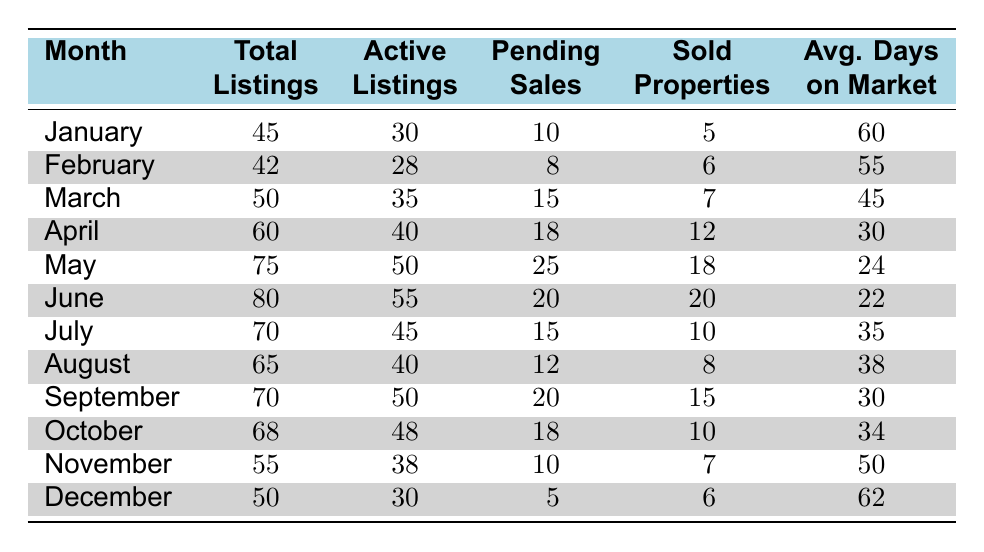What was the total number of listings in May? In May, the table shows a row for that month indicating that the total number of listings is 75.
Answer: 75 What are the average days on the market in June? Looking at the row for June, the average days on the market is listed as 22.
Answer: 22 How many sold properties were there in April? The table indicates that in April, there were 12 sold properties as per the respective row.
Answer: 12 What is the difference in active listings between January and February? In January, there are 30 active listings, and in February, there are 28. The difference is 30 - 28 = 2.
Answer: 2 Which month had the highest total listings? Upon reviewing the total listings for each month, May has the highest total with 75 listings.
Answer: May Was the number of pending sales higher in September than in October? In September, there are 20 pending sales, while in October there are 18. Thus, September has more pending sales.
Answer: Yes What is the sum of sold properties from January to March? Adding the sold properties from January (5), February (6), and March (7) gives us a total of 5 + 6 + 7 = 18.
Answer: 18 How did the average days on market change from February to July? In February, the average days on market is 55, and in July it is 35. The change is 55 - 35 = 20 less days on market.
Answer: 20 Which month had fewer total listings, November or December? In November, there are 55 total listings, while in December there are 50. Since 50 is less than 55, December has fewer listings.
Answer: December What is the average of the average days on the market from January to April? The average days on the market for January (60), February (55), March (45), and April (30) gives us 60 + 55 + 45 + 30 = 190. The average is 190 / 4 = 47.5.
Answer: 47.5 What was the month with the most active listings, and how many were there? The month with the most active listings is June, which had 55 active listings according to the respective row.
Answer: June, 55 